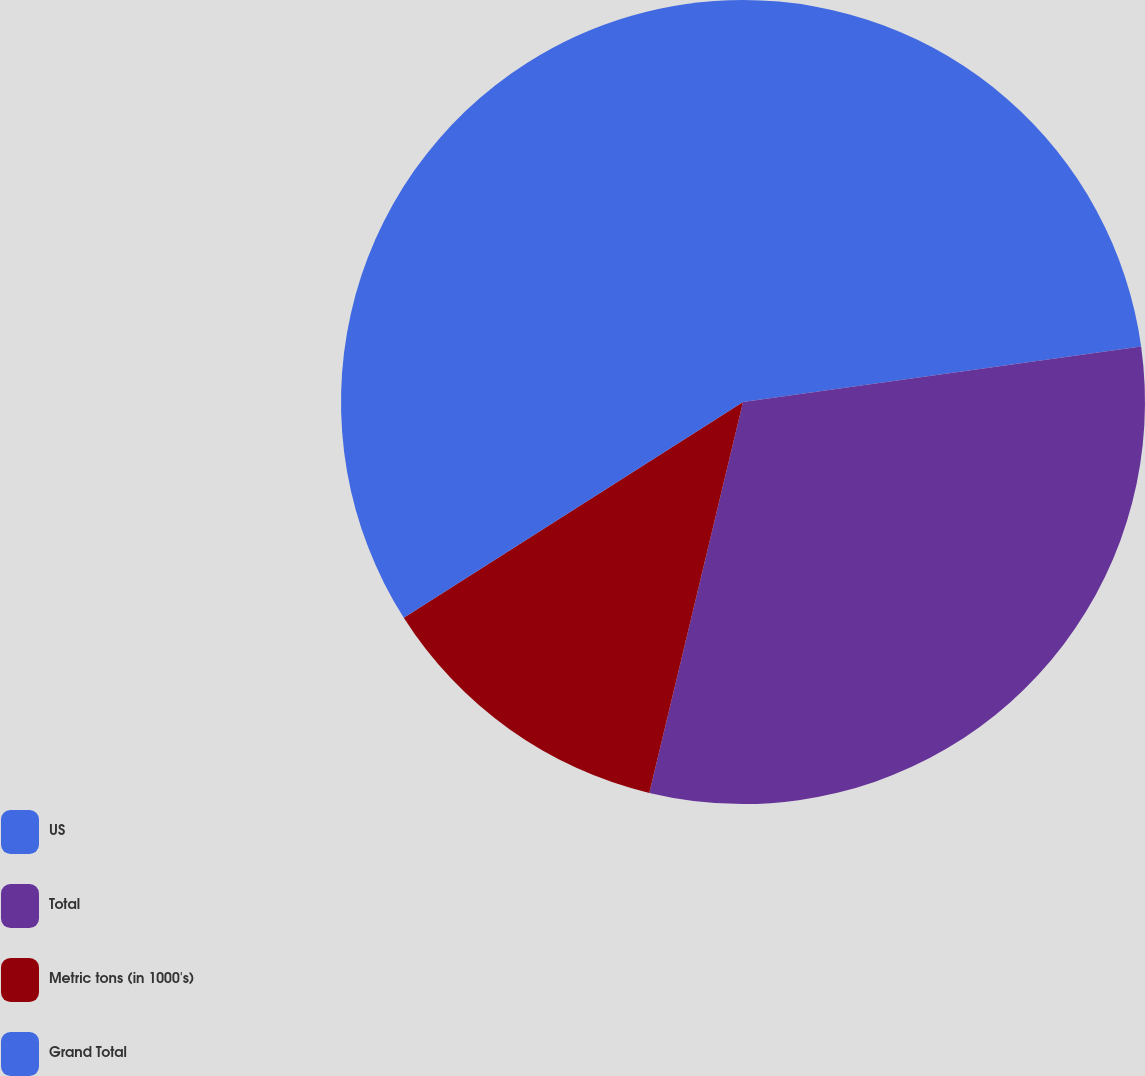Convert chart. <chart><loc_0><loc_0><loc_500><loc_500><pie_chart><fcel>US<fcel>Total<fcel>Metric tons (in 1000's)<fcel>Grand Total<nl><fcel>22.79%<fcel>30.95%<fcel>12.24%<fcel>34.01%<nl></chart> 